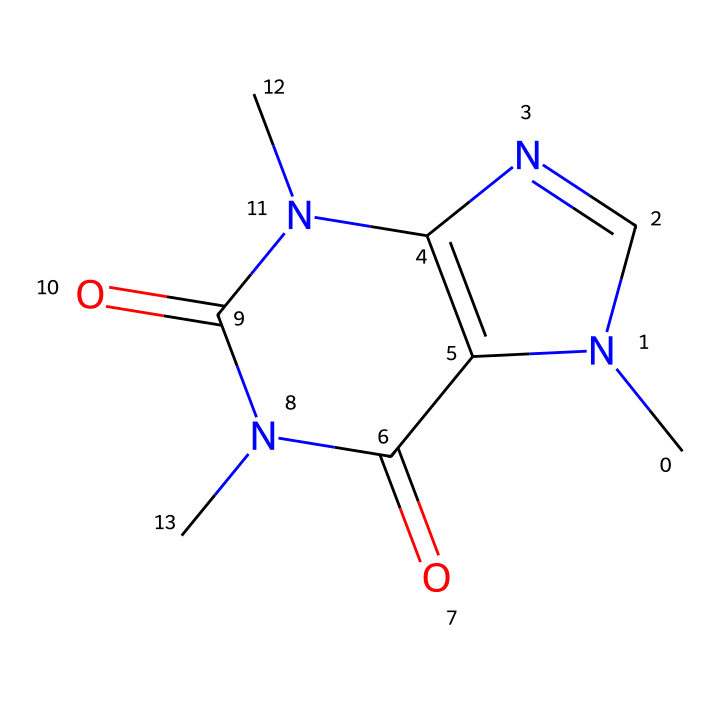What is the molecular formula of caffeine based on its structure? By analyzing the chemical structure, we can count the number of carbon (C), hydrogen (H), nitrogen (N), and oxygen (O) atoms present. There are 8 carbons, 10 hydrogens, 4 nitrogens, and 2 oxygens, leading to the formula C8H10N4O2.
Answer: C8H10N4O2 How many nitrogen atoms are in the chemical structure of caffeine? Looking at the structure, there are four distinct nitrogen atoms present in the formula. These are identifiable by their location and typical representation in the structure as part of the rings.
Answer: 4 Is caffeine classified as a strong base or a weak base? Analyzing the structure shows multiple nitrogen atoms, but the presence of electron-withdrawing functional groups suggests it is not a strong base. By definition, caffeine can be classified as a weak base due to its limited ability to accept protons.
Answer: weak base What functional groups are present in the caffeine structure? Upon examining the structure, we can identify imide (due to the carbonyl adjacent to nitrogen atoms) and amine groups (due to lone pairs on nitrogen), indicating the presence of both types is characteristic of caffeine.
Answer: imide, amine Does caffeine exhibit resonance within its structure? By examining the arrangement of double bonds and lone pairs, we find that nitrogen atoms can delocalize their electrons to adjacent carbonyl groups, creating multiple resonance contributors to the molecule.
Answer: yes What type of chemical structure does caffeine represent? The arrangement of atoms and bonds reveals that caffeine contains both an imide and alkaloid structure, characteristic of stimulants commonly found in energy drinks.
Answer: imide, alkaloid 